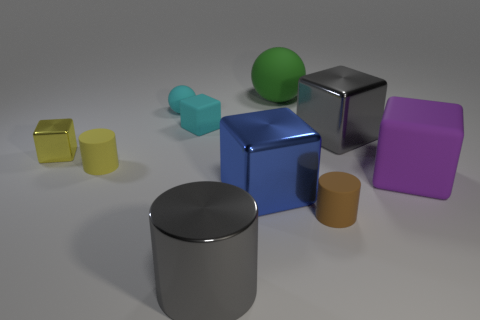What is the color of the metallic cube that is to the left of the gray shiny object in front of the tiny yellow matte cylinder? The metallic cube to the left of the gray shiny object, which is in front of the tiny yellow matte cylinder, is blue. 